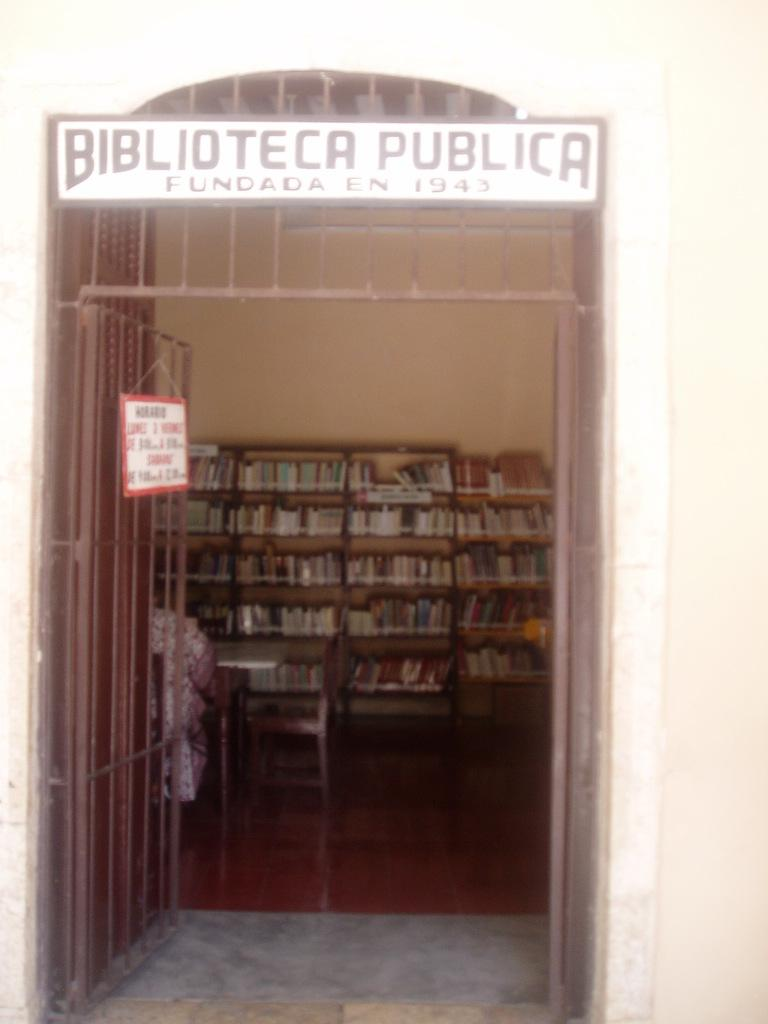Provide a one-sentence caption for the provided image. An open gate with a sign that says BIBLIOTECA PUBLICA. 